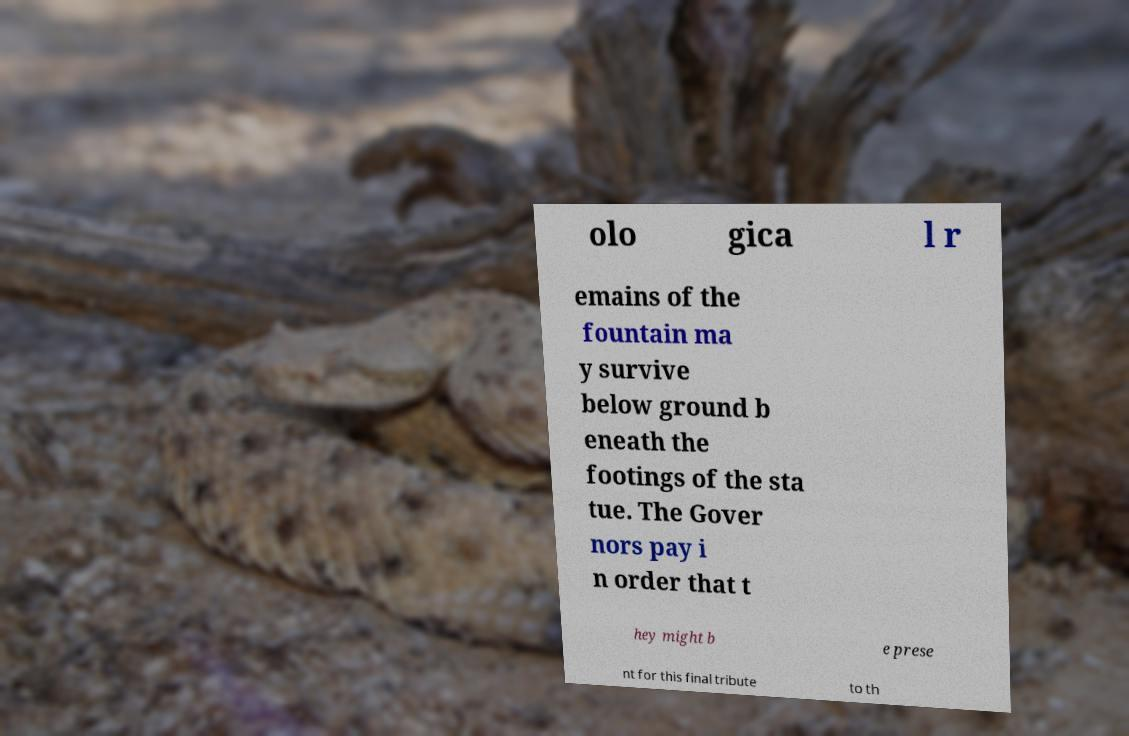Can you read and provide the text displayed in the image?This photo seems to have some interesting text. Can you extract and type it out for me? olo gica l r emains of the fountain ma y survive below ground b eneath the footings of the sta tue. The Gover nors pay i n order that t hey might b e prese nt for this final tribute to th 